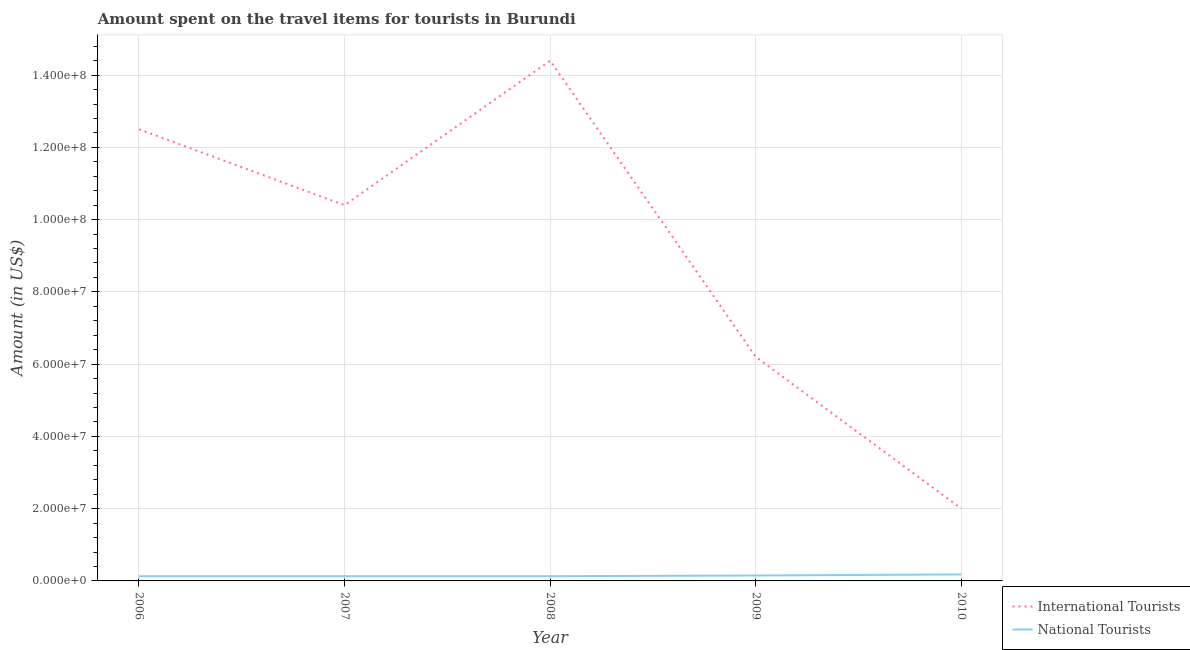Does the line corresponding to amount spent on travel items of national tourists intersect with the line corresponding to amount spent on travel items of international tourists?
Offer a very short reply. No. Is the number of lines equal to the number of legend labels?
Make the answer very short. Yes. What is the amount spent on travel items of international tourists in 2010?
Give a very brief answer. 2.00e+07. Across all years, what is the maximum amount spent on travel items of national tourists?
Give a very brief answer. 1.80e+06. Across all years, what is the minimum amount spent on travel items of national tourists?
Make the answer very short. 1.30e+06. What is the total amount spent on travel items of international tourists in the graph?
Give a very brief answer. 4.55e+08. What is the difference between the amount spent on travel items of national tourists in 2008 and that in 2009?
Your answer should be very brief. -2.00e+05. What is the difference between the amount spent on travel items of international tourists in 2006 and the amount spent on travel items of national tourists in 2008?
Give a very brief answer. 1.24e+08. What is the average amount spent on travel items of international tourists per year?
Give a very brief answer. 9.10e+07. In the year 2010, what is the difference between the amount spent on travel items of national tourists and amount spent on travel items of international tourists?
Keep it short and to the point. -1.82e+07. In how many years, is the amount spent on travel items of international tourists greater than 116000000 US$?
Give a very brief answer. 2. What is the ratio of the amount spent on travel items of national tourists in 2007 to that in 2008?
Ensure brevity in your answer.  1. Is the difference between the amount spent on travel items of national tourists in 2007 and 2008 greater than the difference between the amount spent on travel items of international tourists in 2007 and 2008?
Make the answer very short. Yes. What is the difference between the highest and the second highest amount spent on travel items of international tourists?
Make the answer very short. 1.90e+07. What is the difference between the highest and the lowest amount spent on travel items of national tourists?
Your answer should be very brief. 5.00e+05. Is the amount spent on travel items of national tourists strictly less than the amount spent on travel items of international tourists over the years?
Make the answer very short. Yes. What is the difference between two consecutive major ticks on the Y-axis?
Your answer should be very brief. 2.00e+07. Are the values on the major ticks of Y-axis written in scientific E-notation?
Provide a short and direct response. Yes. Does the graph contain any zero values?
Give a very brief answer. No. Does the graph contain grids?
Keep it short and to the point. Yes. Where does the legend appear in the graph?
Ensure brevity in your answer.  Bottom right. How many legend labels are there?
Offer a terse response. 2. How are the legend labels stacked?
Offer a terse response. Vertical. What is the title of the graph?
Give a very brief answer. Amount spent on the travel items for tourists in Burundi. Does "Not attending school" appear as one of the legend labels in the graph?
Provide a short and direct response. No. What is the label or title of the X-axis?
Your answer should be compact. Year. What is the Amount (in US$) of International Tourists in 2006?
Give a very brief answer. 1.25e+08. What is the Amount (in US$) in National Tourists in 2006?
Give a very brief answer. 1.30e+06. What is the Amount (in US$) in International Tourists in 2007?
Ensure brevity in your answer.  1.04e+08. What is the Amount (in US$) of National Tourists in 2007?
Offer a terse response. 1.30e+06. What is the Amount (in US$) in International Tourists in 2008?
Your response must be concise. 1.44e+08. What is the Amount (in US$) in National Tourists in 2008?
Give a very brief answer. 1.30e+06. What is the Amount (in US$) of International Tourists in 2009?
Offer a very short reply. 6.20e+07. What is the Amount (in US$) of National Tourists in 2009?
Keep it short and to the point. 1.50e+06. What is the Amount (in US$) in National Tourists in 2010?
Make the answer very short. 1.80e+06. Across all years, what is the maximum Amount (in US$) in International Tourists?
Keep it short and to the point. 1.44e+08. Across all years, what is the maximum Amount (in US$) in National Tourists?
Your response must be concise. 1.80e+06. Across all years, what is the minimum Amount (in US$) of International Tourists?
Your answer should be compact. 2.00e+07. Across all years, what is the minimum Amount (in US$) of National Tourists?
Offer a very short reply. 1.30e+06. What is the total Amount (in US$) in International Tourists in the graph?
Your answer should be very brief. 4.55e+08. What is the total Amount (in US$) in National Tourists in the graph?
Provide a short and direct response. 7.20e+06. What is the difference between the Amount (in US$) in International Tourists in 2006 and that in 2007?
Make the answer very short. 2.10e+07. What is the difference between the Amount (in US$) of International Tourists in 2006 and that in 2008?
Your response must be concise. -1.90e+07. What is the difference between the Amount (in US$) of International Tourists in 2006 and that in 2009?
Give a very brief answer. 6.30e+07. What is the difference between the Amount (in US$) in International Tourists in 2006 and that in 2010?
Give a very brief answer. 1.05e+08. What is the difference between the Amount (in US$) of National Tourists in 2006 and that in 2010?
Offer a very short reply. -5.00e+05. What is the difference between the Amount (in US$) of International Tourists in 2007 and that in 2008?
Ensure brevity in your answer.  -4.00e+07. What is the difference between the Amount (in US$) in International Tourists in 2007 and that in 2009?
Ensure brevity in your answer.  4.20e+07. What is the difference between the Amount (in US$) in International Tourists in 2007 and that in 2010?
Offer a very short reply. 8.40e+07. What is the difference between the Amount (in US$) in National Tourists in 2007 and that in 2010?
Your answer should be very brief. -5.00e+05. What is the difference between the Amount (in US$) in International Tourists in 2008 and that in 2009?
Make the answer very short. 8.20e+07. What is the difference between the Amount (in US$) of National Tourists in 2008 and that in 2009?
Your answer should be compact. -2.00e+05. What is the difference between the Amount (in US$) of International Tourists in 2008 and that in 2010?
Ensure brevity in your answer.  1.24e+08. What is the difference between the Amount (in US$) of National Tourists in 2008 and that in 2010?
Provide a short and direct response. -5.00e+05. What is the difference between the Amount (in US$) of International Tourists in 2009 and that in 2010?
Offer a terse response. 4.20e+07. What is the difference between the Amount (in US$) of National Tourists in 2009 and that in 2010?
Keep it short and to the point. -3.00e+05. What is the difference between the Amount (in US$) in International Tourists in 2006 and the Amount (in US$) in National Tourists in 2007?
Make the answer very short. 1.24e+08. What is the difference between the Amount (in US$) in International Tourists in 2006 and the Amount (in US$) in National Tourists in 2008?
Ensure brevity in your answer.  1.24e+08. What is the difference between the Amount (in US$) of International Tourists in 2006 and the Amount (in US$) of National Tourists in 2009?
Your response must be concise. 1.24e+08. What is the difference between the Amount (in US$) of International Tourists in 2006 and the Amount (in US$) of National Tourists in 2010?
Your answer should be compact. 1.23e+08. What is the difference between the Amount (in US$) of International Tourists in 2007 and the Amount (in US$) of National Tourists in 2008?
Offer a terse response. 1.03e+08. What is the difference between the Amount (in US$) of International Tourists in 2007 and the Amount (in US$) of National Tourists in 2009?
Your answer should be compact. 1.02e+08. What is the difference between the Amount (in US$) in International Tourists in 2007 and the Amount (in US$) in National Tourists in 2010?
Keep it short and to the point. 1.02e+08. What is the difference between the Amount (in US$) of International Tourists in 2008 and the Amount (in US$) of National Tourists in 2009?
Make the answer very short. 1.42e+08. What is the difference between the Amount (in US$) of International Tourists in 2008 and the Amount (in US$) of National Tourists in 2010?
Provide a succinct answer. 1.42e+08. What is the difference between the Amount (in US$) of International Tourists in 2009 and the Amount (in US$) of National Tourists in 2010?
Keep it short and to the point. 6.02e+07. What is the average Amount (in US$) of International Tourists per year?
Your response must be concise. 9.10e+07. What is the average Amount (in US$) in National Tourists per year?
Ensure brevity in your answer.  1.44e+06. In the year 2006, what is the difference between the Amount (in US$) in International Tourists and Amount (in US$) in National Tourists?
Your answer should be very brief. 1.24e+08. In the year 2007, what is the difference between the Amount (in US$) in International Tourists and Amount (in US$) in National Tourists?
Give a very brief answer. 1.03e+08. In the year 2008, what is the difference between the Amount (in US$) in International Tourists and Amount (in US$) in National Tourists?
Your answer should be compact. 1.43e+08. In the year 2009, what is the difference between the Amount (in US$) of International Tourists and Amount (in US$) of National Tourists?
Offer a terse response. 6.05e+07. In the year 2010, what is the difference between the Amount (in US$) in International Tourists and Amount (in US$) in National Tourists?
Offer a very short reply. 1.82e+07. What is the ratio of the Amount (in US$) of International Tourists in 2006 to that in 2007?
Your answer should be compact. 1.2. What is the ratio of the Amount (in US$) of International Tourists in 2006 to that in 2008?
Provide a succinct answer. 0.87. What is the ratio of the Amount (in US$) of International Tourists in 2006 to that in 2009?
Provide a succinct answer. 2.02. What is the ratio of the Amount (in US$) in National Tourists in 2006 to that in 2009?
Your response must be concise. 0.87. What is the ratio of the Amount (in US$) in International Tourists in 2006 to that in 2010?
Your answer should be very brief. 6.25. What is the ratio of the Amount (in US$) in National Tourists in 2006 to that in 2010?
Offer a very short reply. 0.72. What is the ratio of the Amount (in US$) of International Tourists in 2007 to that in 2008?
Make the answer very short. 0.72. What is the ratio of the Amount (in US$) in National Tourists in 2007 to that in 2008?
Provide a succinct answer. 1. What is the ratio of the Amount (in US$) in International Tourists in 2007 to that in 2009?
Give a very brief answer. 1.68. What is the ratio of the Amount (in US$) of National Tourists in 2007 to that in 2009?
Ensure brevity in your answer.  0.87. What is the ratio of the Amount (in US$) in International Tourists in 2007 to that in 2010?
Your response must be concise. 5.2. What is the ratio of the Amount (in US$) in National Tourists in 2007 to that in 2010?
Keep it short and to the point. 0.72. What is the ratio of the Amount (in US$) of International Tourists in 2008 to that in 2009?
Your response must be concise. 2.32. What is the ratio of the Amount (in US$) in National Tourists in 2008 to that in 2009?
Offer a terse response. 0.87. What is the ratio of the Amount (in US$) of National Tourists in 2008 to that in 2010?
Your answer should be compact. 0.72. What is the ratio of the Amount (in US$) in National Tourists in 2009 to that in 2010?
Give a very brief answer. 0.83. What is the difference between the highest and the second highest Amount (in US$) of International Tourists?
Offer a terse response. 1.90e+07. What is the difference between the highest and the second highest Amount (in US$) in National Tourists?
Give a very brief answer. 3.00e+05. What is the difference between the highest and the lowest Amount (in US$) in International Tourists?
Your answer should be very brief. 1.24e+08. 